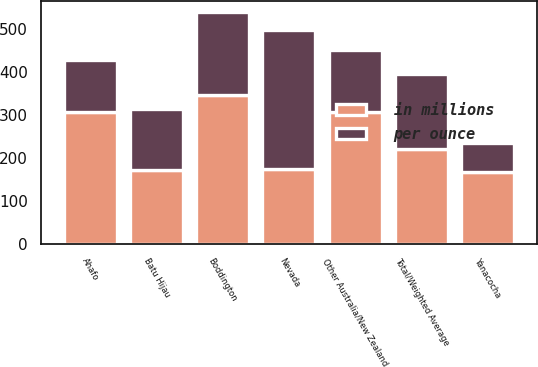Convert chart to OTSL. <chart><loc_0><loc_0><loc_500><loc_500><stacked_bar_chart><ecel><fcel>Nevada<fcel>Yanacocha<fcel>Boddington<fcel>Other Australia/New Zealand<fcel>Batu Hijau<fcel>Ahafo<fcel>Total/Weighted Average<nl><fcel>per ounce<fcel>324<fcel>69<fcel>192<fcel>145<fcel>142<fcel>121<fcel>175<nl><fcel>in millions<fcel>175<fcel>167<fcel>348<fcel>308<fcel>172<fcel>307<fcel>220<nl></chart> 